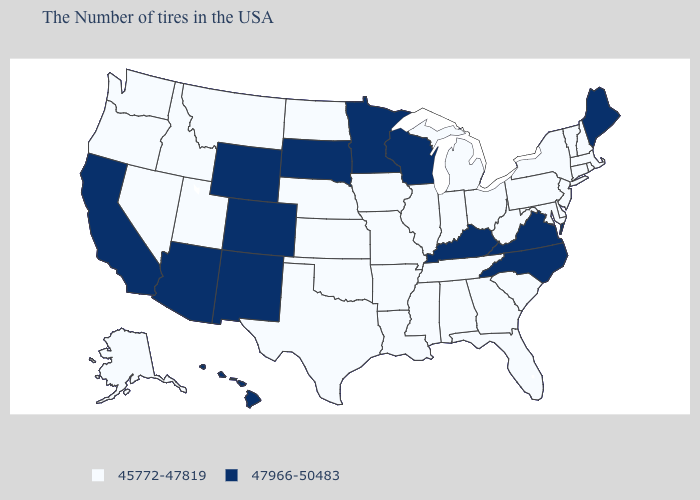Name the states that have a value in the range 47966-50483?
Write a very short answer. Maine, Virginia, North Carolina, Kentucky, Wisconsin, Minnesota, South Dakota, Wyoming, Colorado, New Mexico, Arizona, California, Hawaii. Which states have the lowest value in the West?
Write a very short answer. Utah, Montana, Idaho, Nevada, Washington, Oregon, Alaska. Which states hav the highest value in the West?
Quick response, please. Wyoming, Colorado, New Mexico, Arizona, California, Hawaii. Name the states that have a value in the range 45772-47819?
Short answer required. Massachusetts, Rhode Island, New Hampshire, Vermont, Connecticut, New York, New Jersey, Delaware, Maryland, Pennsylvania, South Carolina, West Virginia, Ohio, Florida, Georgia, Michigan, Indiana, Alabama, Tennessee, Illinois, Mississippi, Louisiana, Missouri, Arkansas, Iowa, Kansas, Nebraska, Oklahoma, Texas, North Dakota, Utah, Montana, Idaho, Nevada, Washington, Oregon, Alaska. Which states have the lowest value in the South?
Answer briefly. Delaware, Maryland, South Carolina, West Virginia, Florida, Georgia, Alabama, Tennessee, Mississippi, Louisiana, Arkansas, Oklahoma, Texas. Does Alabama have a lower value than Nevada?
Short answer required. No. Which states have the highest value in the USA?
Quick response, please. Maine, Virginia, North Carolina, Kentucky, Wisconsin, Minnesota, South Dakota, Wyoming, Colorado, New Mexico, Arizona, California, Hawaii. Name the states that have a value in the range 47966-50483?
Write a very short answer. Maine, Virginia, North Carolina, Kentucky, Wisconsin, Minnesota, South Dakota, Wyoming, Colorado, New Mexico, Arizona, California, Hawaii. What is the value of Colorado?
Keep it brief. 47966-50483. Name the states that have a value in the range 45772-47819?
Be succinct. Massachusetts, Rhode Island, New Hampshire, Vermont, Connecticut, New York, New Jersey, Delaware, Maryland, Pennsylvania, South Carolina, West Virginia, Ohio, Florida, Georgia, Michigan, Indiana, Alabama, Tennessee, Illinois, Mississippi, Louisiana, Missouri, Arkansas, Iowa, Kansas, Nebraska, Oklahoma, Texas, North Dakota, Utah, Montana, Idaho, Nevada, Washington, Oregon, Alaska. Which states have the highest value in the USA?
Be succinct. Maine, Virginia, North Carolina, Kentucky, Wisconsin, Minnesota, South Dakota, Wyoming, Colorado, New Mexico, Arizona, California, Hawaii. Among the states that border Indiana , does Ohio have the lowest value?
Concise answer only. Yes. Is the legend a continuous bar?
Be succinct. No. What is the value of Hawaii?
Quick response, please. 47966-50483. What is the value of Oklahoma?
Give a very brief answer. 45772-47819. 